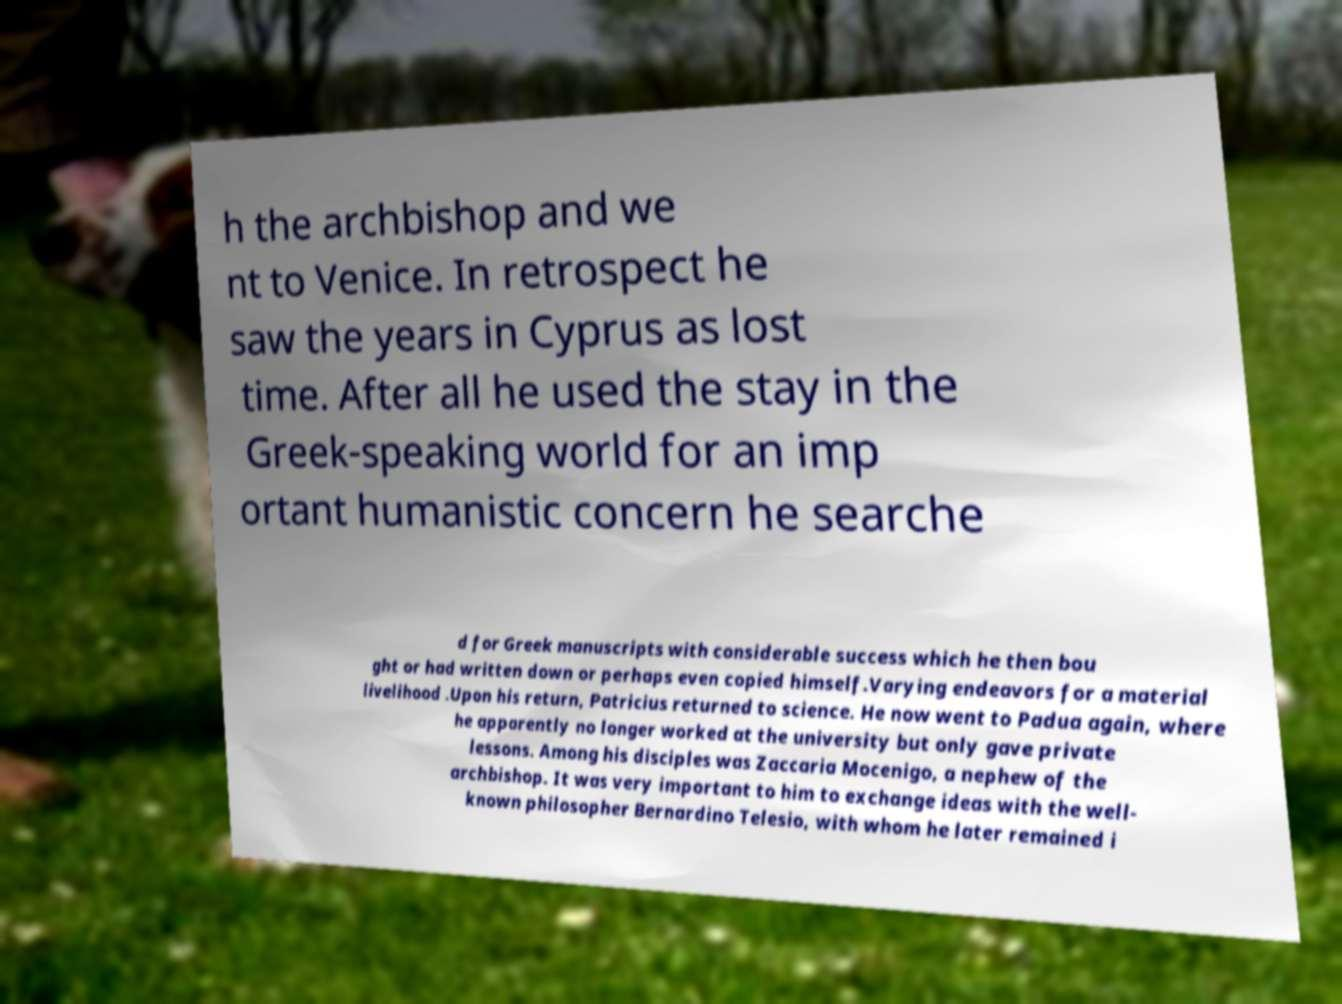Could you extract and type out the text from this image? h the archbishop and we nt to Venice. In retrospect he saw the years in Cyprus as lost time. After all he used the stay in the Greek-speaking world for an imp ortant humanistic concern he searche d for Greek manuscripts with considerable success which he then bou ght or had written down or perhaps even copied himself.Varying endeavors for a material livelihood .Upon his return, Patricius returned to science. He now went to Padua again, where he apparently no longer worked at the university but only gave private lessons. Among his disciples was Zaccaria Mocenigo, a nephew of the archbishop. It was very important to him to exchange ideas with the well- known philosopher Bernardino Telesio, with whom he later remained i 